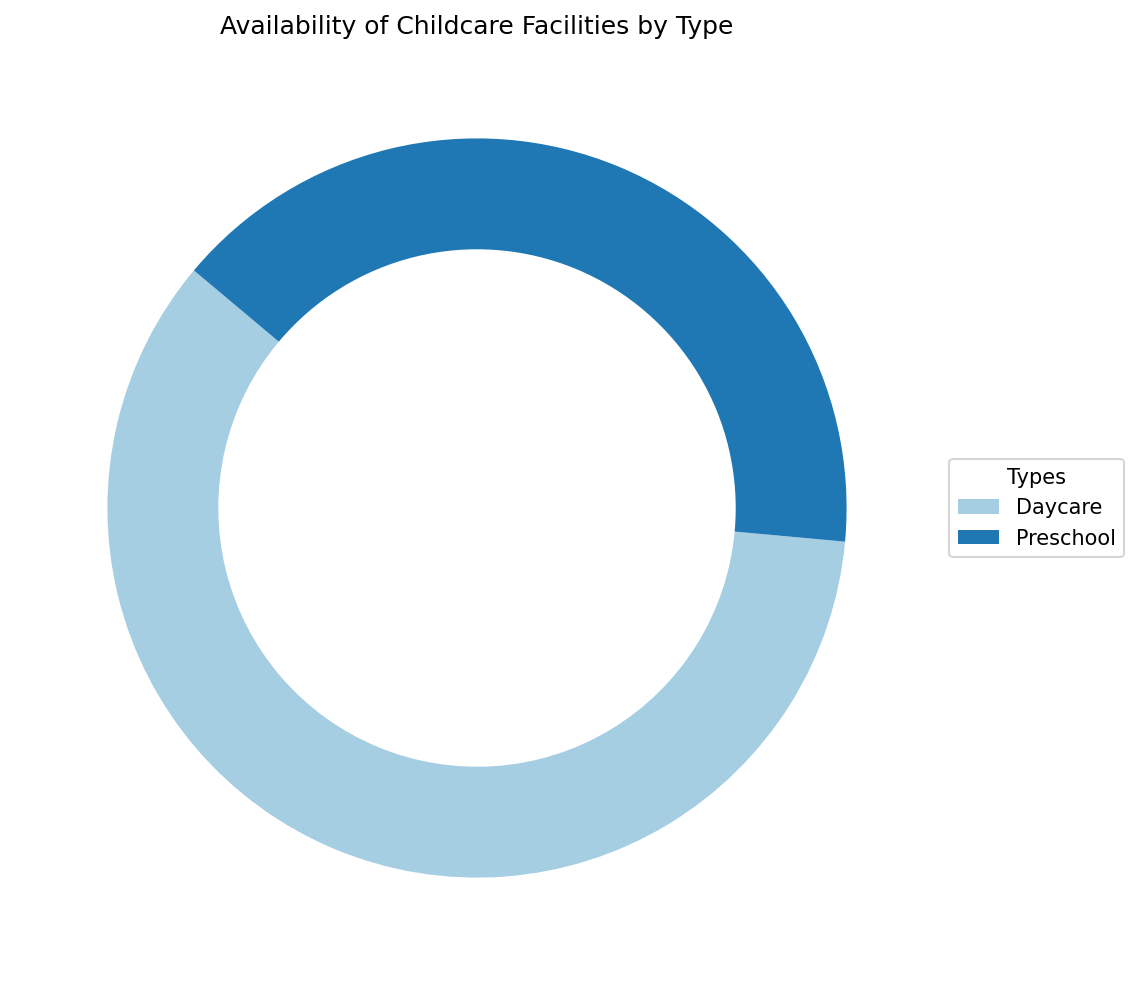What's the total availability of childcare facilities across all types? To find the total availability, add up the availabilities of all types from the ring chart. Daycare and Preschool have 105 and 71 availabilities respectively, so total is 105 + 71.
Answer: 176 Which type of childcare facility has a higher availability? Compare the sections of the ring chart. Daycare has 105 and Preschool has 71; clearly, Daycare has higher availability.
Answer: Daycare Between Daycare and Preschool, which one constitutes a larger percentage of the total availability? Given that Daycare has 105 and Preschool has 71 availabilities, calculate their percentages. Daycare: (105/176)*100 ≈ 59.7%, Preschool: (71/176)*100 ≈ 40.3%.
Answer: Daycare What's the difference in availability between Daycare and Preschool facilities? Subtract Preschool availabilities from Daycare. So it is 105 - 71.
Answer: 34 If one suburban area is chosen randomly, which type of facility is more likely to be available? Based on the percentages, since Daycare has the larger share of 59.7%, choosing randomly means it's more likely to be a Daycare facility.
Answer: Daycare By what factor is the availability of Daycare more than that of Preschool? Divide the availability of Daycare by Preschool. So it is 105 / 71 ≈ 1.48.
Answer: 1.48 What visual feature differentiates Daycare availability from Preschool? Daycare's section is visibly larger than Preschool's in the ring chart, indicative of higher availability.
Answer: Larger section How many suburban areas have more than 10 facilities of any type? Check the data for facilities greater than 10. Areas A, B, D, E, and G in Daycare and Areas B, E, and G in Preschool.
Answer: 5 What's the share of the childcare facilities that are Preschools? Calculate the Preschool percentage: (71/176) * 100 ≈ 40.3%.
Answer: 40.3% 